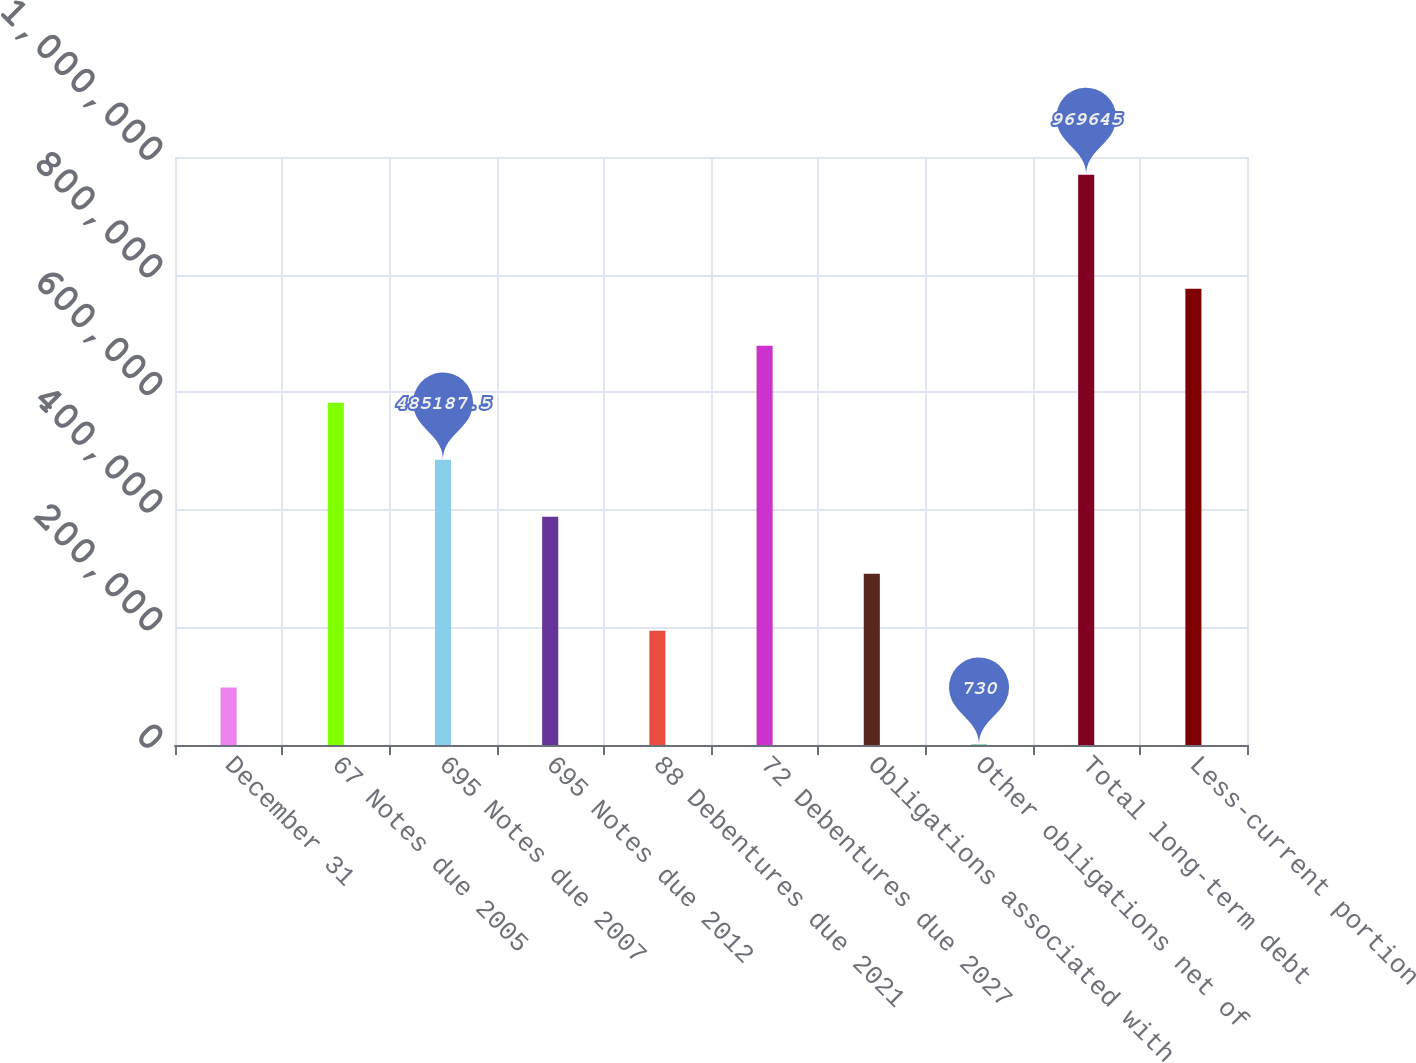<chart> <loc_0><loc_0><loc_500><loc_500><bar_chart><fcel>December 31<fcel>67 Notes due 2005<fcel>695 Notes due 2007<fcel>695 Notes due 2012<fcel>88 Debentures due 2021<fcel>72 Debentures due 2027<fcel>Obligations associated with<fcel>Other obligations net of<fcel>Total long-term debt<fcel>Less-current portion<nl><fcel>97621.5<fcel>582079<fcel>485188<fcel>388296<fcel>194513<fcel>678970<fcel>291404<fcel>730<fcel>969645<fcel>775862<nl></chart> 